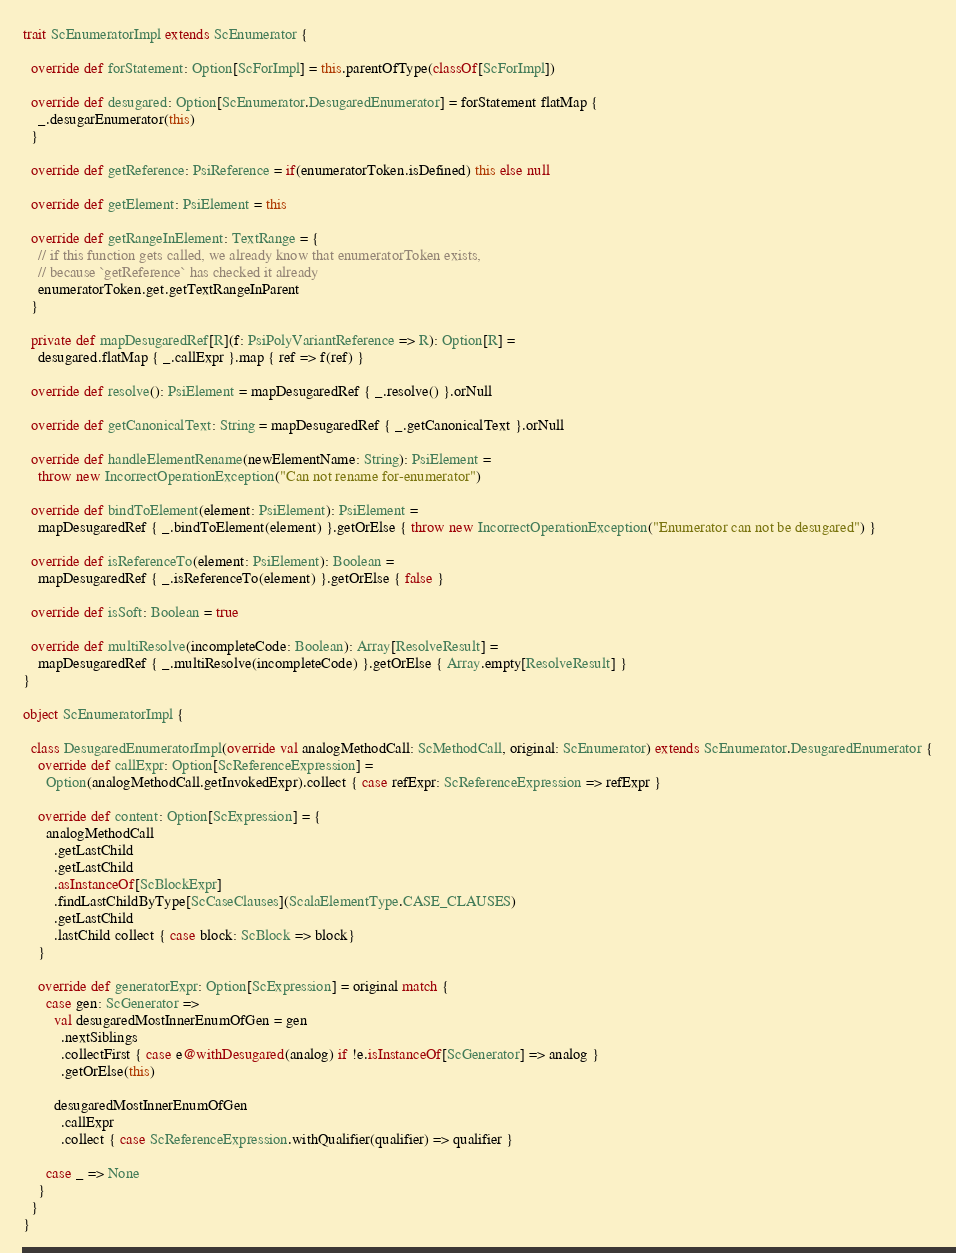Convert code to text. <code><loc_0><loc_0><loc_500><loc_500><_Scala_>trait ScEnumeratorImpl extends ScEnumerator {

  override def forStatement: Option[ScForImpl] = this.parentOfType(classOf[ScForImpl])

  override def desugared: Option[ScEnumerator.DesugaredEnumerator] = forStatement flatMap {
    _.desugarEnumerator(this)
  }

  override def getReference: PsiReference = if(enumeratorToken.isDefined) this else null

  override def getElement: PsiElement = this

  override def getRangeInElement: TextRange = {
    // if this function gets called, we already know that enumeratorToken exists,
    // because `getReference` has checked it already
    enumeratorToken.get.getTextRangeInParent
  }

  private def mapDesugaredRef[R](f: PsiPolyVariantReference => R): Option[R] =
    desugared.flatMap { _.callExpr }.map { ref => f(ref) }

  override def resolve(): PsiElement = mapDesugaredRef { _.resolve() }.orNull

  override def getCanonicalText: String = mapDesugaredRef { _.getCanonicalText }.orNull

  override def handleElementRename(newElementName: String): PsiElement =
    throw new IncorrectOperationException("Can not rename for-enumerator")

  override def bindToElement(element: PsiElement): PsiElement =
    mapDesugaredRef { _.bindToElement(element) }.getOrElse { throw new IncorrectOperationException("Enumerator can not be desugared") }

  override def isReferenceTo(element: PsiElement): Boolean =
    mapDesugaredRef { _.isReferenceTo(element) }.getOrElse { false }

  override def isSoft: Boolean = true

  override def multiResolve(incompleteCode: Boolean): Array[ResolveResult] =
    mapDesugaredRef { _.multiResolve(incompleteCode) }.getOrElse { Array.empty[ResolveResult] }
}

object ScEnumeratorImpl {

  class DesugaredEnumeratorImpl(override val analogMethodCall: ScMethodCall, original: ScEnumerator) extends ScEnumerator.DesugaredEnumerator {
    override def callExpr: Option[ScReferenceExpression] =
      Option(analogMethodCall.getInvokedExpr).collect { case refExpr: ScReferenceExpression => refExpr }

    override def content: Option[ScExpression] = {
      analogMethodCall
        .getLastChild
        .getLastChild
        .asInstanceOf[ScBlockExpr]
        .findLastChildByType[ScCaseClauses](ScalaElementType.CASE_CLAUSES)
        .getLastChild
        .lastChild collect { case block: ScBlock => block}
    }

    override def generatorExpr: Option[ScExpression] = original match {
      case gen: ScGenerator =>
        val desugaredMostInnerEnumOfGen = gen
          .nextSiblings
          .collectFirst { case e@withDesugared(analog) if !e.isInstanceOf[ScGenerator] => analog }
          .getOrElse(this)

        desugaredMostInnerEnumOfGen
          .callExpr
          .collect { case ScReferenceExpression.withQualifier(qualifier) => qualifier }

      case _ => None
    }
  }
}</code> 